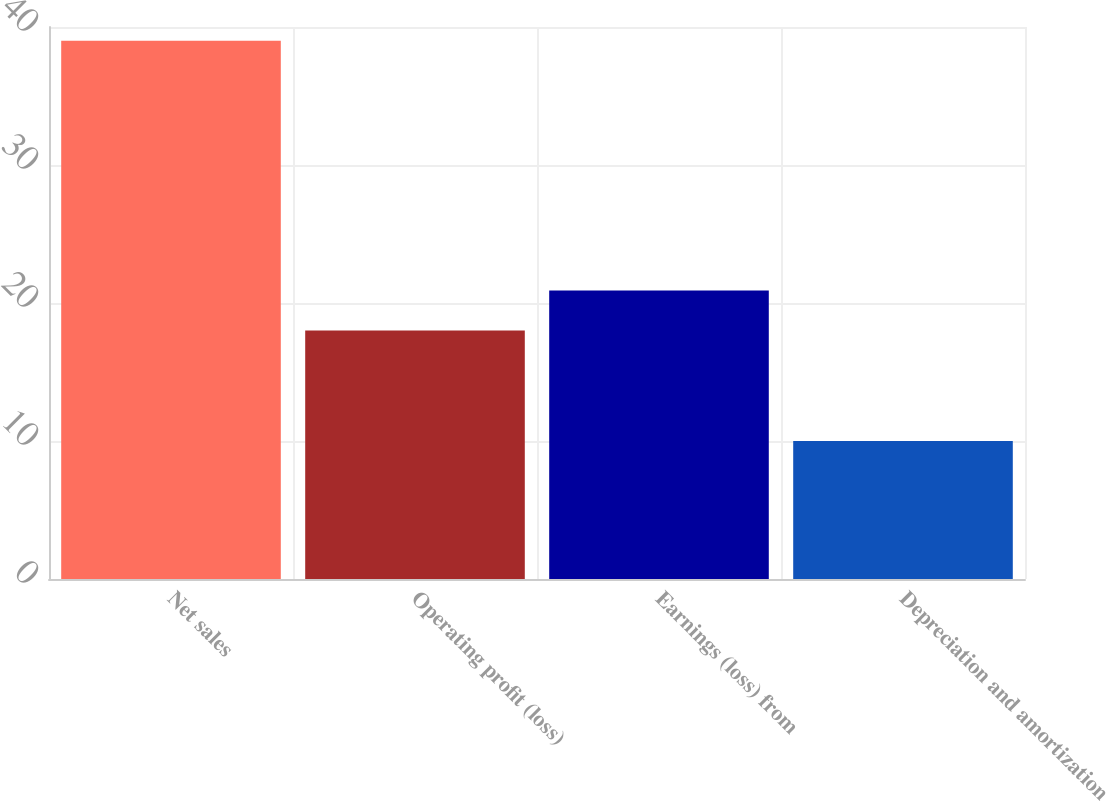Convert chart. <chart><loc_0><loc_0><loc_500><loc_500><bar_chart><fcel>Net sales<fcel>Operating profit (loss)<fcel>Earnings (loss) from<fcel>Depreciation and amortization<nl><fcel>39<fcel>18<fcel>20.9<fcel>10<nl></chart> 